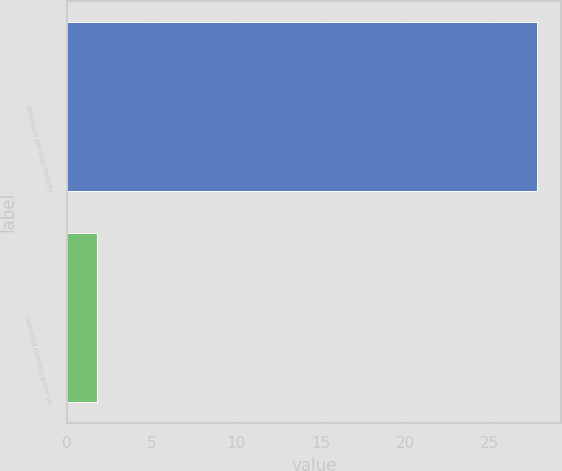Convert chart to OTSL. <chart><loc_0><loc_0><loc_500><loc_500><bar_chart><fcel>Minimum pension liability<fcel>Deferred (losses) gains on<nl><fcel>27.8<fcel>1.8<nl></chart> 